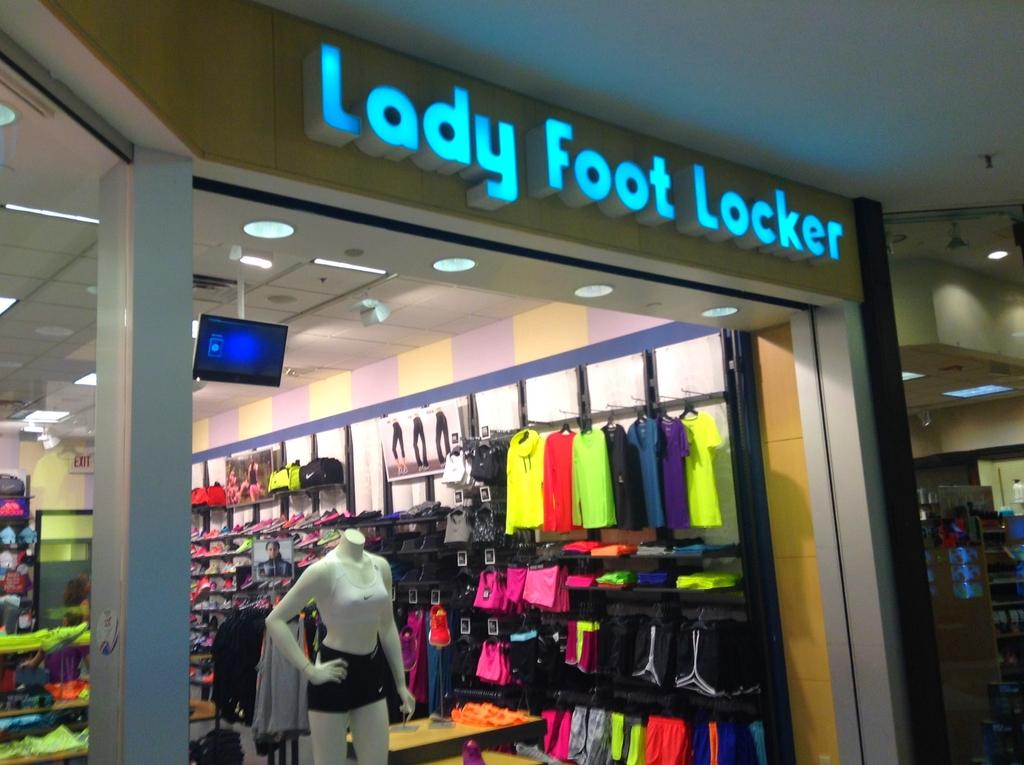What type of establishment is depicted in the image? The location is a clothing store. What can be seen in front of the store? There is a mannequin in front of the store. Can you see any clouds in the image? There is no reference to clouds in the image, as it features a clothing store with a mannequin in front of it. Are there any baseball players visible in the image? There is no reference to baseball players in the image; it features a clothing store with a mannequin in front of it. 